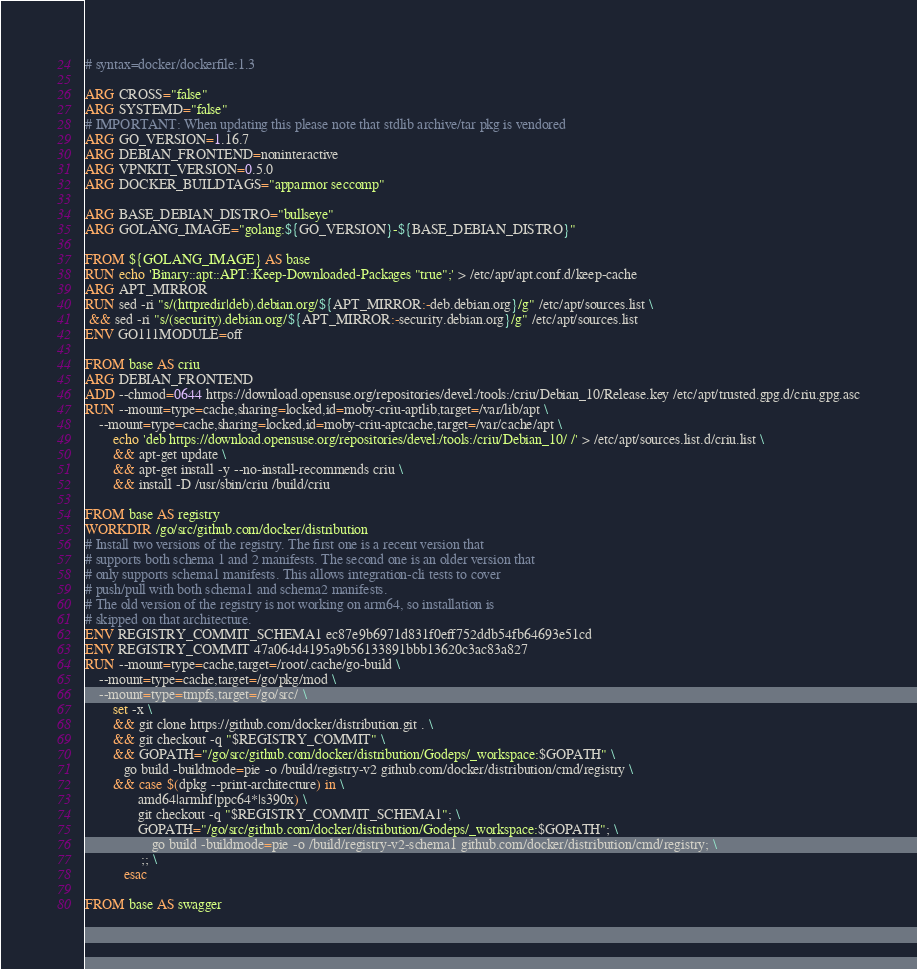<code> <loc_0><loc_0><loc_500><loc_500><_Dockerfile_># syntax=docker/dockerfile:1.3

ARG CROSS="false"
ARG SYSTEMD="false"
# IMPORTANT: When updating this please note that stdlib archive/tar pkg is vendored
ARG GO_VERSION=1.16.7
ARG DEBIAN_FRONTEND=noninteractive
ARG VPNKIT_VERSION=0.5.0
ARG DOCKER_BUILDTAGS="apparmor seccomp"

ARG BASE_DEBIAN_DISTRO="bullseye"
ARG GOLANG_IMAGE="golang:${GO_VERSION}-${BASE_DEBIAN_DISTRO}"

FROM ${GOLANG_IMAGE} AS base
RUN echo 'Binary::apt::APT::Keep-Downloaded-Packages "true";' > /etc/apt/apt.conf.d/keep-cache
ARG APT_MIRROR
RUN sed -ri "s/(httpredir|deb).debian.org/${APT_MIRROR:-deb.debian.org}/g" /etc/apt/sources.list \
 && sed -ri "s/(security).debian.org/${APT_MIRROR:-security.debian.org}/g" /etc/apt/sources.list
ENV GO111MODULE=off

FROM base AS criu
ARG DEBIAN_FRONTEND
ADD --chmod=0644 https://download.opensuse.org/repositories/devel:/tools:/criu/Debian_10/Release.key /etc/apt/trusted.gpg.d/criu.gpg.asc
RUN --mount=type=cache,sharing=locked,id=moby-criu-aptlib,target=/var/lib/apt \
    --mount=type=cache,sharing=locked,id=moby-criu-aptcache,target=/var/cache/apt \
        echo 'deb https://download.opensuse.org/repositories/devel:/tools:/criu/Debian_10/ /' > /etc/apt/sources.list.d/criu.list \
        && apt-get update \
        && apt-get install -y --no-install-recommends criu \
        && install -D /usr/sbin/criu /build/criu

FROM base AS registry
WORKDIR /go/src/github.com/docker/distribution
# Install two versions of the registry. The first one is a recent version that
# supports both schema 1 and 2 manifests. The second one is an older version that
# only supports schema1 manifests. This allows integration-cli tests to cover
# push/pull with both schema1 and schema2 manifests.
# The old version of the registry is not working on arm64, so installation is
# skipped on that architecture.
ENV REGISTRY_COMMIT_SCHEMA1 ec87e9b6971d831f0eff752ddb54fb64693e51cd
ENV REGISTRY_COMMIT 47a064d4195a9b56133891bbb13620c3ac83a827
RUN --mount=type=cache,target=/root/.cache/go-build \
    --mount=type=cache,target=/go/pkg/mod \
    --mount=type=tmpfs,target=/go/src/ \
        set -x \
        && git clone https://github.com/docker/distribution.git . \
        && git checkout -q "$REGISTRY_COMMIT" \
        && GOPATH="/go/src/github.com/docker/distribution/Godeps/_workspace:$GOPATH" \
           go build -buildmode=pie -o /build/registry-v2 github.com/docker/distribution/cmd/registry \
        && case $(dpkg --print-architecture) in \
               amd64|armhf|ppc64*|s390x) \
               git checkout -q "$REGISTRY_COMMIT_SCHEMA1"; \
               GOPATH="/go/src/github.com/docker/distribution/Godeps/_workspace:$GOPATH"; \
                   go build -buildmode=pie -o /build/registry-v2-schema1 github.com/docker/distribution/cmd/registry; \
                ;; \
           esac

FROM base AS swagger</code> 